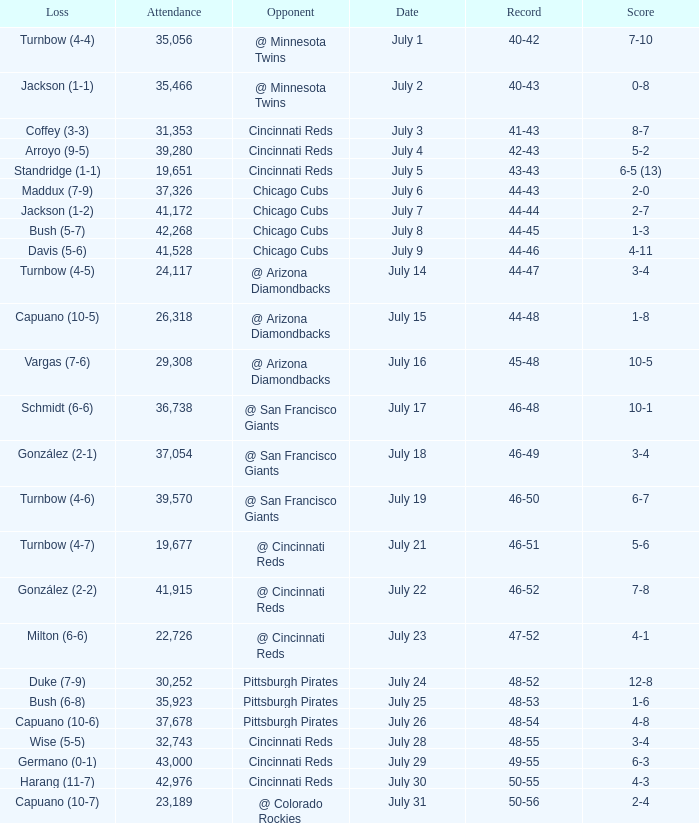What was the record at the game that had a score of 7-10? 40-42. 